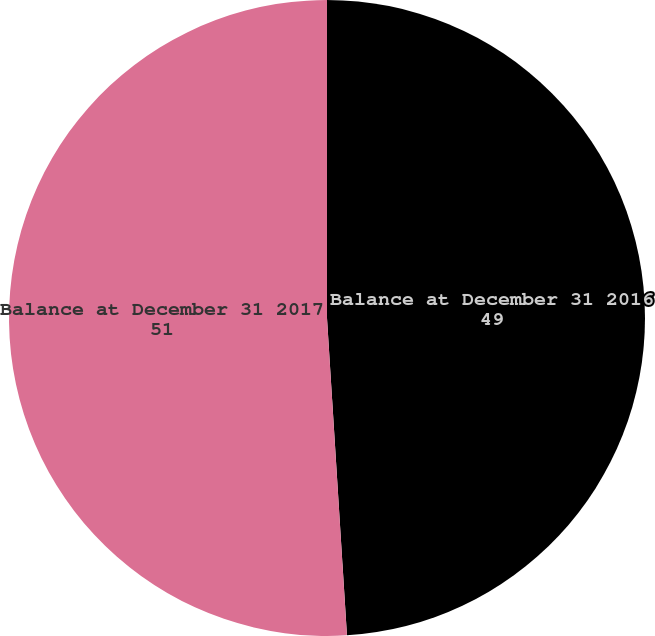Convert chart to OTSL. <chart><loc_0><loc_0><loc_500><loc_500><pie_chart><fcel>Balance at December 31 2016<fcel>Balance at December 31 2017<nl><fcel>49.0%<fcel>51.0%<nl></chart> 